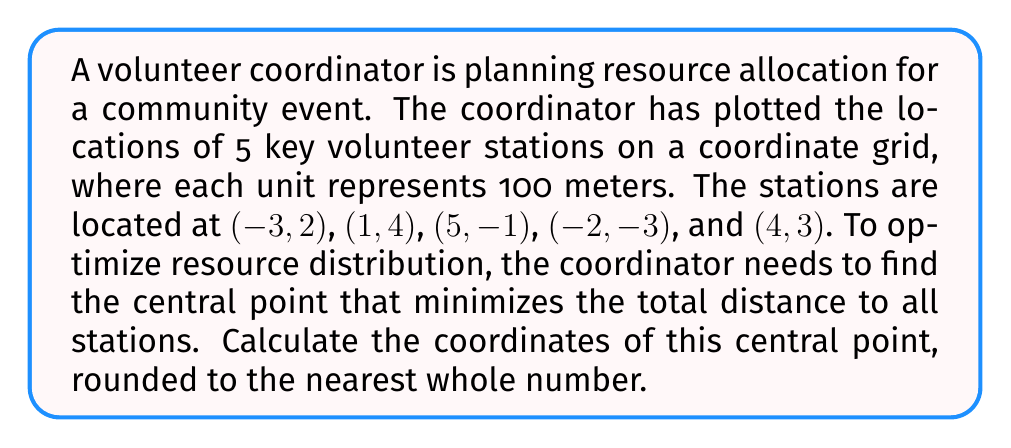What is the answer to this math problem? To find the central point that minimizes the total distance to all stations, we need to calculate the centroid of the given points. The centroid is the arithmetic mean position of all the points in a set.

Step 1: Calculate the average x-coordinate
$$\bar{x} = \frac{\sum_{i=1}^n x_i}{n}$$

Where $x_i$ are the x-coordinates of each point, and $n$ is the total number of points.

$$\bar{x} = \frac{(-3) + 1 + 5 + (-2) + 4}{5} = \frac{5}{5} = 1$$

Step 2: Calculate the average y-coordinate
$$\bar{y} = \frac{\sum_{i=1}^n y_i}{n}$$

Where $y_i$ are the y-coordinates of each point.

$$\bar{y} = \frac{2 + 4 + (-1) + (-3) + 3}{5} = \frac{5}{5} = 1$$

Step 3: The centroid coordinates are $(\bar{x}, \bar{y})$, which in this case is (1, 1).

Since we need to round to the nearest whole number, and both coordinates are already whole numbers, no further rounding is necessary.

[asy]
unitsize(1cm);
draw((-5,-5)--(6,-5)--(6,5)--(-5,5)--cycle);
for(int i=-5; i<=6; ++i) {
  draw((i,-5)--(i,5),gray+0.5bp);
  draw((-5,i)--(6,i),gray+0.5bp);
}

dot((-3,2),red);
dot((1,4),red);
dot((5,-1),red);
dot((-2,-3),red);
dot((4,3),red);
dot((1,1),blue);

label("(-3,2)", (-3,2), NE);
label("(1,4)", (1,4), NE);
label("(5,-1)", (5,-1), SE);
label("(-2,-3)", (-2,-3), SW);
label("(4,3)", (4,3), NE);
label("(1,1)", (1,1), SE);

draw((-5,0)--(6,0),Arrow);
draw((0,-5)--(0,5),Arrow);
label("x", (6,0), E);
label("y", (0,5), N);
[/asy]
Answer: The central point that minimizes the total distance to all volunteer stations is (1, 1). 